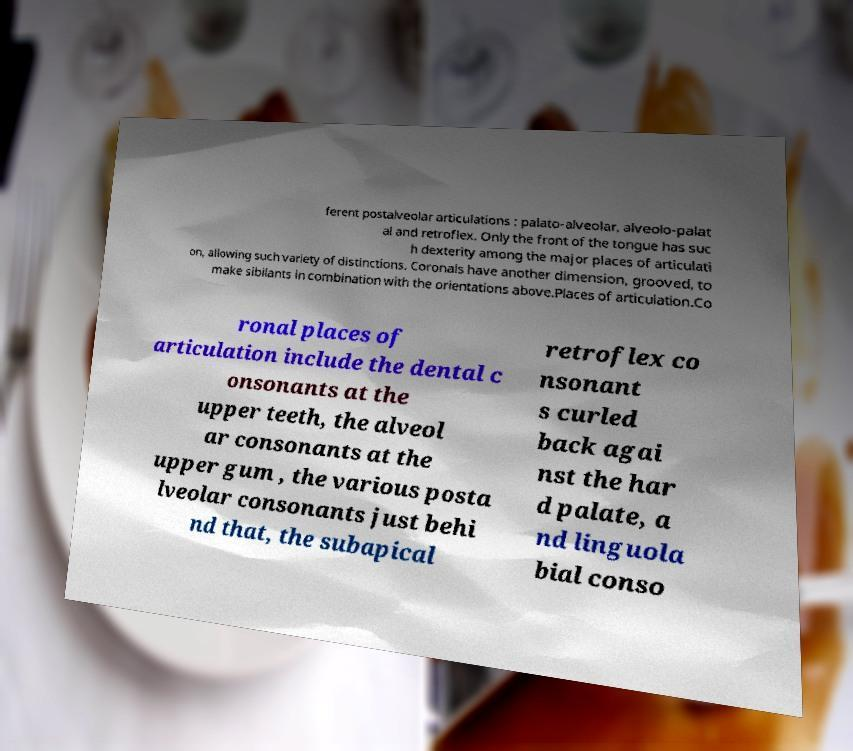Could you assist in decoding the text presented in this image and type it out clearly? ferent postalveolar articulations : palato-alveolar, alveolo-palat al and retroflex. Only the front of the tongue has suc h dexterity among the major places of articulati on, allowing such variety of distinctions. Coronals have another dimension, grooved, to make sibilants in combination with the orientations above.Places of articulation.Co ronal places of articulation include the dental c onsonants at the upper teeth, the alveol ar consonants at the upper gum , the various posta lveolar consonants just behi nd that, the subapical retroflex co nsonant s curled back agai nst the har d palate, a nd linguola bial conso 